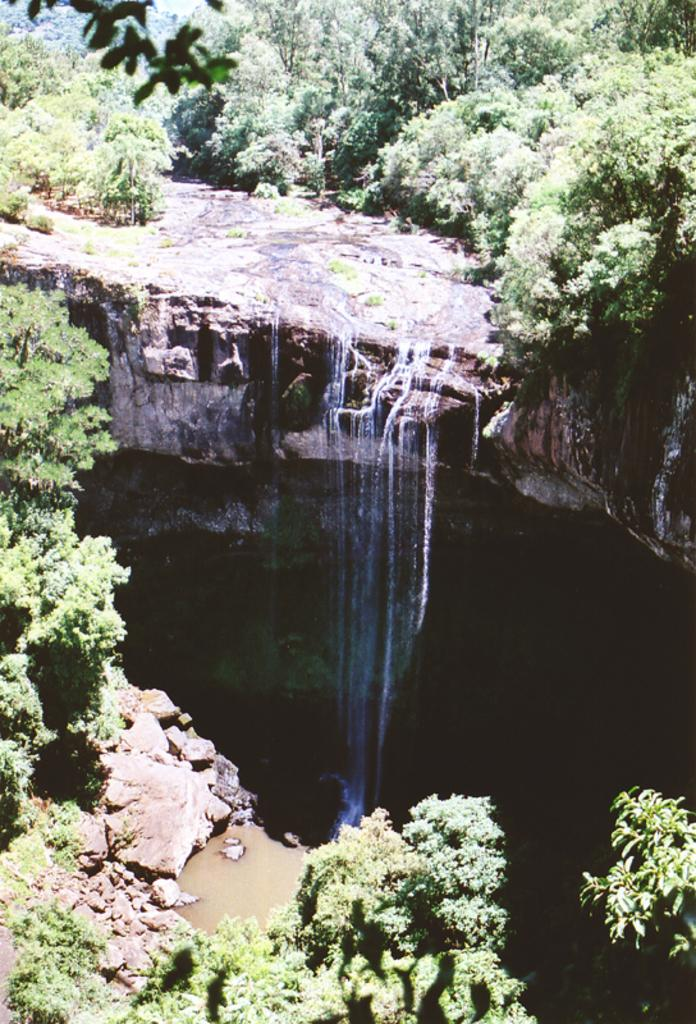What type of vegetation can be seen in the image? There are trees and plants in the image. What natural feature is located in the middle of the image? There is a waterfall in the middle of the image. How many spiders are crawling on the waterfall in the image? There are no spiders present in the image; it features trees, plants, and a waterfall. What type of bread can be seen near the waterfall in the image? There is no bread present in the image; it only features trees, plants, and a waterfall. 